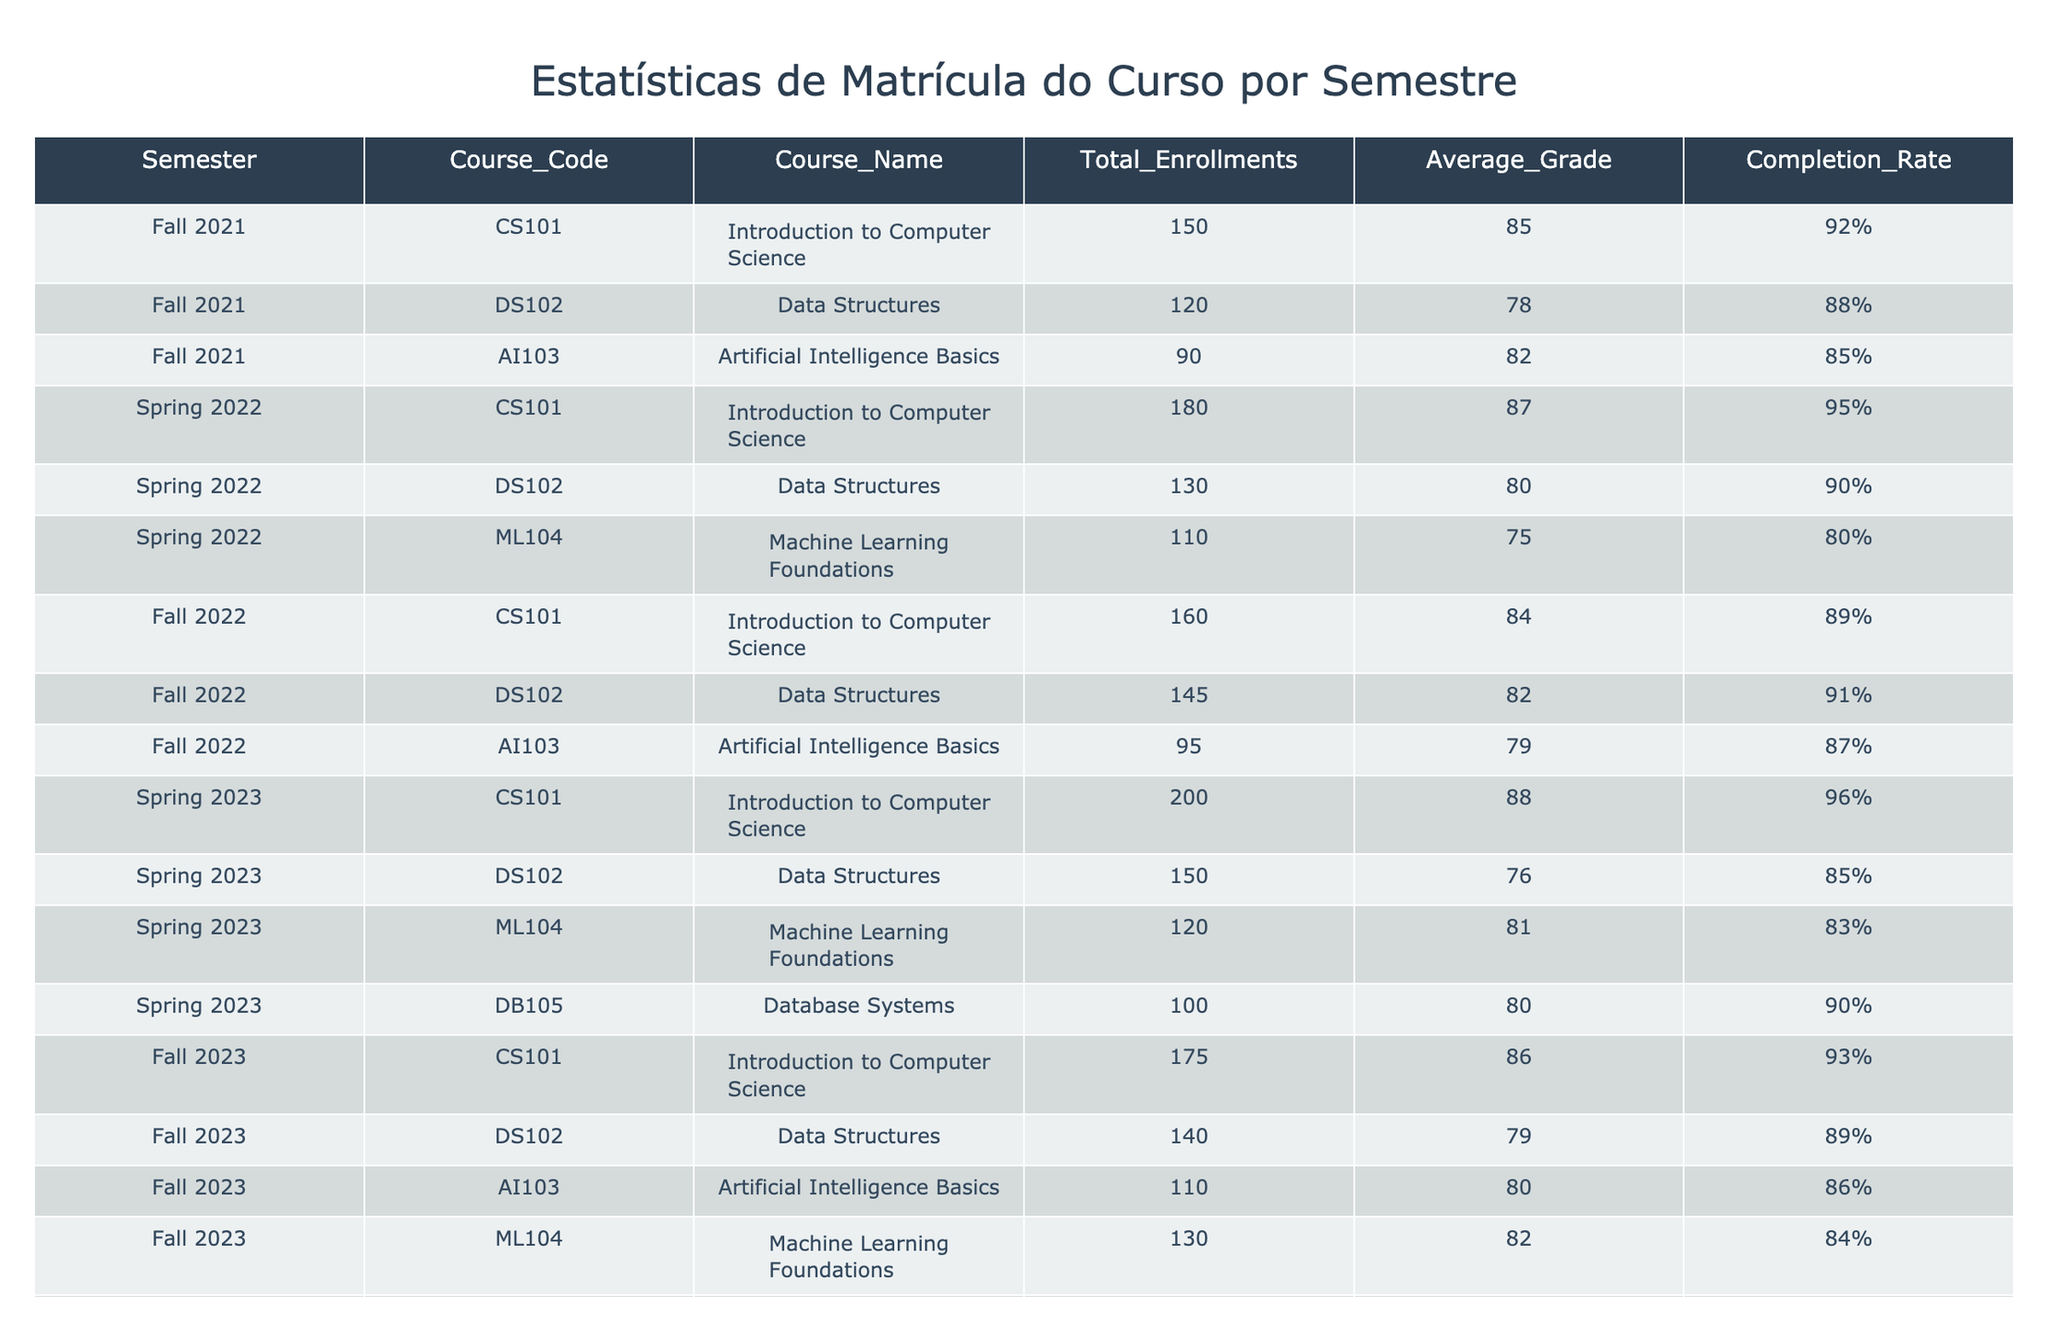Qual foi o total de matrículas no curso "Machine Learning Foundations" no semestre de Primavera de 2023? A partir da tabela, procuramos a linha correspondente ao semestre "Spring 2023" e ao curso "ML104". O total de matrículas para este curso nesse semestre é 120.
Answer: 120 Qual foi a taxa de conclusão do curso "Introdução à Ciência da Computação" no semestre de Outono de 2022? Localizando a linha correspondente a "Fall 2022" e "CS101", encontramos a taxa de conclusão. O valor apresentado é 89%, que é a resposta.
Answer: 89% Durante quais semestres o curso "Data Structures" teve uma média de notas abaixo de 80? Analisando as médias de notas do curso "DS102" em cada semestre, observamos que a média foi 78 em "Fall 2021", 80 em "Spring 2022", e 76 em "Spring 2023". Portanto, somente "Spring 2023" apresenta uma média abaixo de 80.
Answer: Spring 2023 Qual é a taxa de conclusão média dos cursos oferecidos no semestre de Outono de 2023? Primeiro, extraímos as taxas de conclusão de todos os cursos no semestre "Fall 2023": 93% (CS101), 89% (DS102), 86% (AI103), 84% (ML104), e 88% (DB105). Somamos essas taxas: 93 + 89 + 86 + 84 + 88 = 440. Dividindo pelo número de cursos (5), obtemos 440/5 = 88%.
Answer: 88% O curso "Artificial Intelligence Basics" teve mais matrículas em "Fall 2022" do que em "Fall 2023"? Verificando as matrículas para "AI103", encontramos 95 em "Fall 2022" e 110 em "Fall 2023". Como 110 é maior que 95, a resposta é não.
Answer: Não Quais cursos tiveram uma taxa de conclusão superior a 90% no semestre de Primavera de 2022? Para responder, analisamos a tabela da "Spring 2022" e verificamos as taxas de conclusão: CS101 teve 95%, DS102 teve 90%, e ML104 teve 80%. Apenas "CS101" superou 90%, com 95%.
Answer: CS101 Qual foi a variação de matrículas no curso "Data Structures" entre "Fall 2021" e "Fall 2023"? Para calcular a variação, olhamos para as matrículas do curso "DS102": 120 em "Fall 2021" e 140 em "Fall 2023". A variação é 140 - 120 = 20. Portanto, houve um aumento de 20 matrículas entre esses semestres.
Answer: 20 Em qual semestre o curso "Database Systems" teve a média de notas mais baixa? Analisamos as notas médias para "DB105" em cada semestre: não há dados para "Fall 2021", mas temos 80 em "Spring 2023" e 78 em "Fall 2023". Assim, a média mais baixa foi no semestre "Fall 2023".
Answer: Fall 2023 